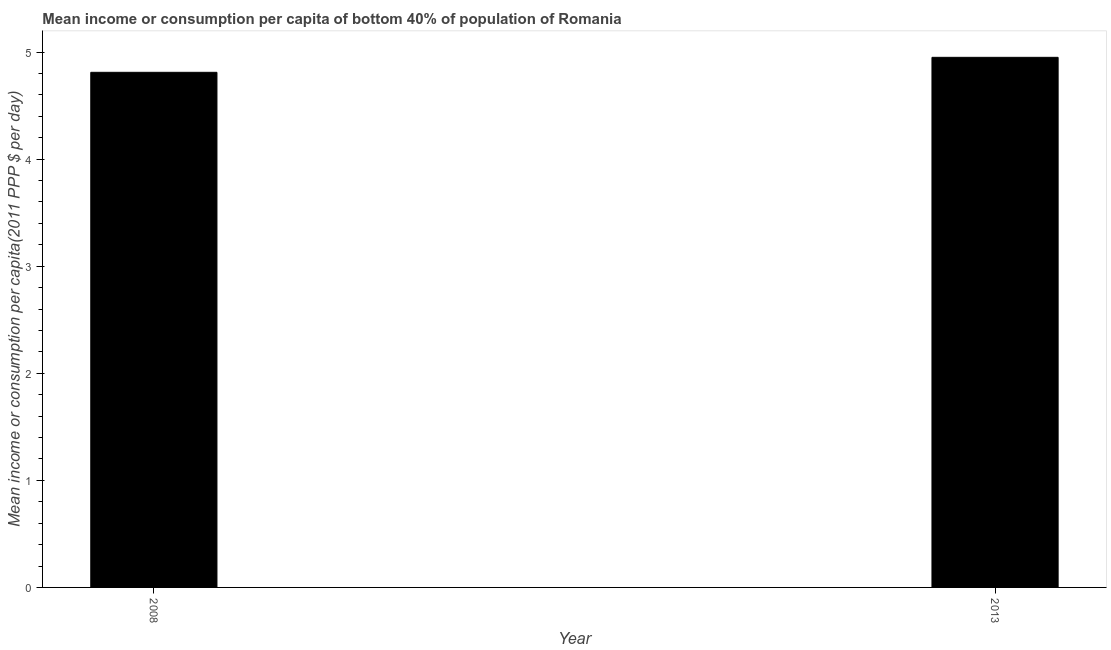Does the graph contain grids?
Your response must be concise. No. What is the title of the graph?
Ensure brevity in your answer.  Mean income or consumption per capita of bottom 40% of population of Romania. What is the label or title of the Y-axis?
Provide a succinct answer. Mean income or consumption per capita(2011 PPP $ per day). What is the mean income or consumption in 2013?
Ensure brevity in your answer.  4.95. Across all years, what is the maximum mean income or consumption?
Your answer should be compact. 4.95. Across all years, what is the minimum mean income or consumption?
Ensure brevity in your answer.  4.81. In which year was the mean income or consumption minimum?
Your response must be concise. 2008. What is the sum of the mean income or consumption?
Keep it short and to the point. 9.76. What is the difference between the mean income or consumption in 2008 and 2013?
Offer a very short reply. -0.14. What is the average mean income or consumption per year?
Provide a succinct answer. 4.88. What is the median mean income or consumption?
Make the answer very short. 4.88. In how many years, is the mean income or consumption greater than 3.2 $?
Offer a terse response. 2. Is the mean income or consumption in 2008 less than that in 2013?
Provide a short and direct response. Yes. In how many years, is the mean income or consumption greater than the average mean income or consumption taken over all years?
Give a very brief answer. 1. How many years are there in the graph?
Keep it short and to the point. 2. What is the difference between two consecutive major ticks on the Y-axis?
Make the answer very short. 1. What is the Mean income or consumption per capita(2011 PPP $ per day) of 2008?
Offer a very short reply. 4.81. What is the Mean income or consumption per capita(2011 PPP $ per day) of 2013?
Give a very brief answer. 4.95. What is the difference between the Mean income or consumption per capita(2011 PPP $ per day) in 2008 and 2013?
Keep it short and to the point. -0.14. 